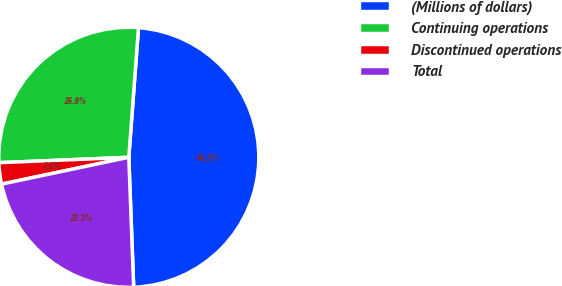<chart> <loc_0><loc_0><loc_500><loc_500><pie_chart><fcel>(Millions of dollars)<fcel>Continuing operations<fcel>Discontinued operations<fcel>Total<nl><fcel>48.22%<fcel>26.85%<fcel>2.65%<fcel>22.29%<nl></chart> 